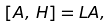Convert formula to latex. <formula><loc_0><loc_0><loc_500><loc_500>\left [ A , \, H \right ] & = L A ,</formula> 